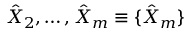Convert formula to latex. <formula><loc_0><loc_0><loc_500><loc_500>\hat { X } _ { 2 } , \dots , \hat { X } _ { m } \equiv \{ \hat { X } _ { m } \}</formula> 